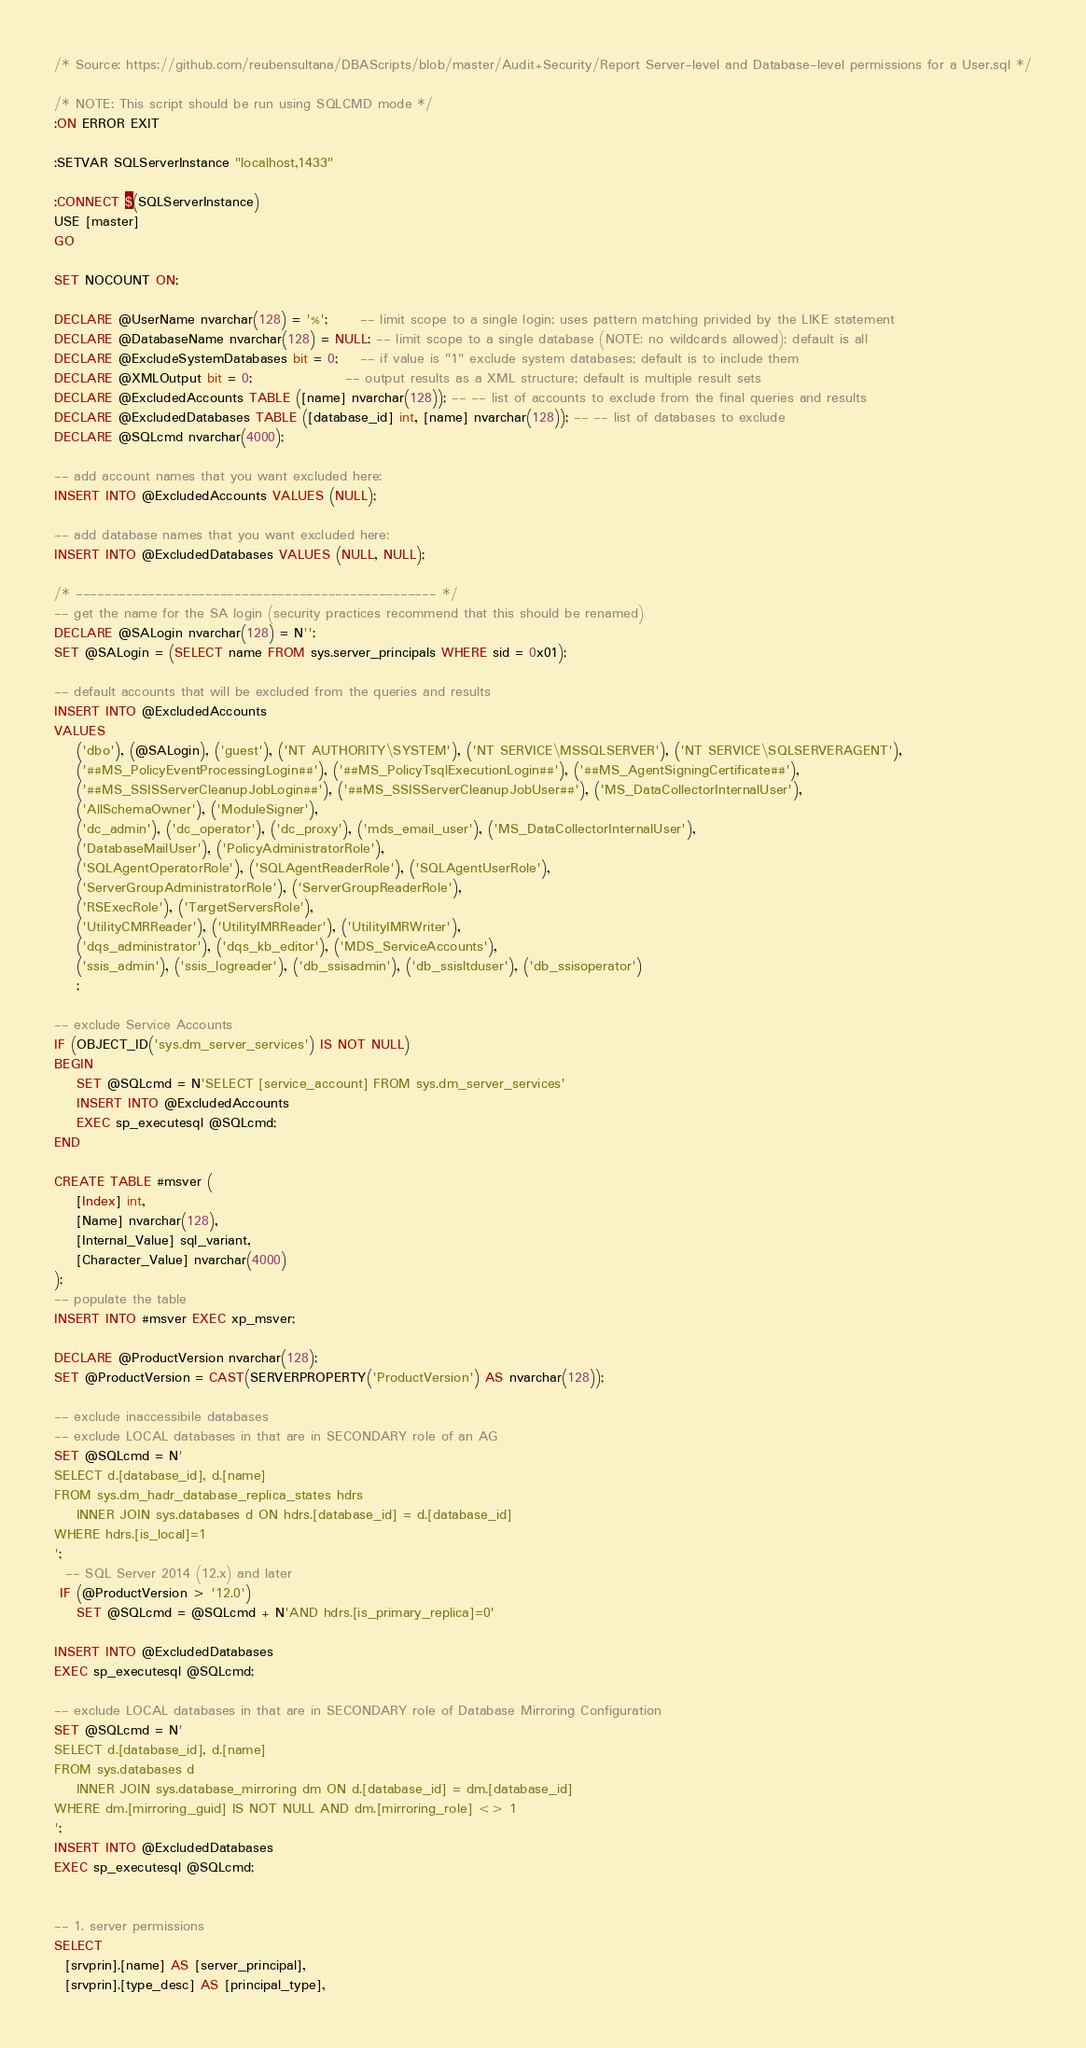<code> <loc_0><loc_0><loc_500><loc_500><_SQL_>/* Source: https://github.com/reubensultana/DBAScripts/blob/master/Audit+Security/Report Server-level and Database-level permissions for a User.sql */

/* NOTE: This script should be run using SQLCMD mode */
:ON ERROR EXIT

:SETVAR SQLServerInstance "localhost,1433"

:CONNECT $(SQLServerInstance)
USE [master]
GO

SET NOCOUNT ON;

DECLARE @UserName nvarchar(128) = '%';      -- limit scope to a single login; uses pattern matching privided by the LIKE statement
DECLARE @DatabaseName nvarchar(128) = NULL; -- limit scope to a single database (NOTE: no wildcards allowed); default is all
DECLARE @ExcludeSystemDatabases bit = 0;    -- if value is "1" exclude system databases; default is to include them
DECLARE @XMLOutput bit = 0;                 -- output results as a XML structure; default is multiple result sets
DECLARE @ExcludedAccounts TABLE ([name] nvarchar(128)); -- -- list of accounts to exclude from the final queries and results
DECLARE @ExcludedDatabases TABLE ([database_id] int, [name] nvarchar(128)); -- -- list of databases to exclude
DECLARE @SQLcmd nvarchar(4000);

-- add account names that you want excluded here:
INSERT INTO @ExcludedAccounts VALUES (NULL);

-- add database names that you want excluded here:
INSERT INTO @ExcludedDatabases VALUES (NULL, NULL);

/* -------------------------------------------------- */
-- get the name for the SA login (security practices recommend that this should be renamed)
DECLARE @SALogin nvarchar(128) = N'';
SET @SALogin = (SELECT name FROM sys.server_principals WHERE sid = 0x01);

-- default accounts that will be excluded from the queries and results
INSERT INTO @ExcludedAccounts 
VALUES 
    ('dbo'), (@SALogin), ('guest'), ('NT AUTHORITY\SYSTEM'), ('NT SERVICE\MSSQLSERVER'), ('NT SERVICE\SQLSERVERAGENT'),
    ('##MS_PolicyEventProcessingLogin##'), ('##MS_PolicyTsqlExecutionLogin##'), ('##MS_AgentSigningCertificate##'),
    ('##MS_SSISServerCleanupJobLogin##'), ('##MS_SSISServerCleanupJobUser##'), ('MS_DataCollectorInternalUser'), 
    ('AllSchemaOwner'), ('ModuleSigner'),
    ('dc_admin'), ('dc_operator'), ('dc_proxy'), ('mds_email_user'), ('MS_DataCollectorInternalUser'), 
    ('DatabaseMailUser'), ('PolicyAdministratorRole'), 
    ('SQLAgentOperatorRole'), ('SQLAgentReaderRole'), ('SQLAgentUserRole'), 
    ('ServerGroupAdministratorRole'), ('ServerGroupReaderRole'), 
    ('RSExecRole'), ('TargetServersRole'), 
    ('UtilityCMRReader'), ('UtilityIMRReader'), ('UtilityIMRWriter'),
    ('dqs_administrator'), ('dqs_kb_editor'), ('MDS_ServiceAccounts'),
    ('ssis_admin'), ('ssis_logreader'), ('db_ssisadmin'), ('db_ssisltduser'), ('db_ssisoperator')
    ;

-- exclude Service Accounts
IF (OBJECT_ID('sys.dm_server_services') IS NOT NULL)
BEGIN
    SET @SQLcmd = N'SELECT [service_account] FROM sys.dm_server_services'
    INSERT INTO @ExcludedAccounts 
    EXEC sp_executesql @SQLcmd;
END

CREATE TABLE #msver (
	[Index] int,
	[Name] nvarchar(128),
	[Internal_Value] sql_variant,
	[Character_Value] nvarchar(4000)
);
-- populate the table
INSERT INTO #msver EXEC xp_msver;

DECLARE @ProductVersion nvarchar(128);
SET @ProductVersion = CAST(SERVERPROPERTY('ProductVersion') AS nvarchar(128));

-- exclude inaccessibile databases
-- exclude LOCAL databases in that are in SECONDARY role of an AG
SET @SQLcmd = N'
SELECT d.[database_id], d.[name]
FROM sys.dm_hadr_database_replica_states hdrs
    INNER JOIN sys.databases d ON hdrs.[database_id] = d.[database_id]
WHERE hdrs.[is_local]=1
';
  -- SQL Server 2014 (12.x) and later
 IF (@ProductVersion > '12.0')
    SET @SQLcmd = @SQLcmd + N'AND hdrs.[is_primary_replica]=0'

INSERT INTO @ExcludedDatabases
EXEC sp_executesql @SQLcmd;

-- exclude LOCAL databases in that are in SECONDARY role of Database Mirroring Configuration
SET @SQLcmd = N'
SELECT d.[database_id], d.[name]
FROM sys.databases d
    INNER JOIN sys.database_mirroring dm ON d.[database_id] = dm.[database_id]
WHERE dm.[mirroring_guid] IS NOT NULL AND dm.[mirroring_role] <> 1
';
INSERT INTO @ExcludedDatabases
EXEC sp_executesql @SQLcmd;


-- 1. server permissions
SELECT 
  [srvprin].[name] AS [server_principal],
  [srvprin].[type_desc] AS [principal_type],</code> 